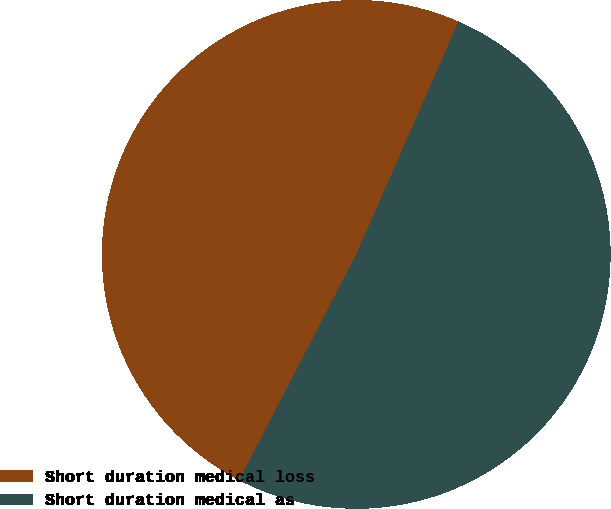<chart> <loc_0><loc_0><loc_500><loc_500><pie_chart><fcel>Short duration medical loss<fcel>Short duration medical as<nl><fcel>48.97%<fcel>51.03%<nl></chart> 